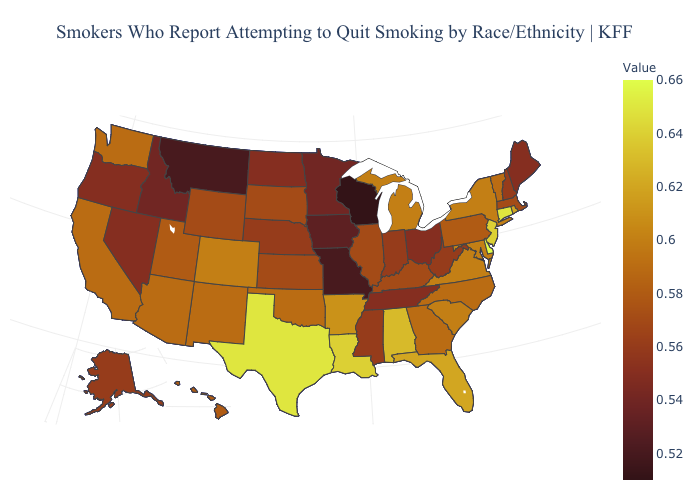Among the states that border Colorado , does Utah have the highest value?
Concise answer only. No. Which states have the lowest value in the South?
Give a very brief answer. Tennessee. Which states hav the highest value in the Northeast?
Write a very short answer. Connecticut. Does Arizona have the highest value in the West?
Answer briefly. No. Does Virginia have the lowest value in the South?
Be succinct. No. Which states hav the highest value in the MidWest?
Keep it brief. Michigan. Among the states that border Wyoming , does Idaho have the highest value?
Keep it brief. No. 